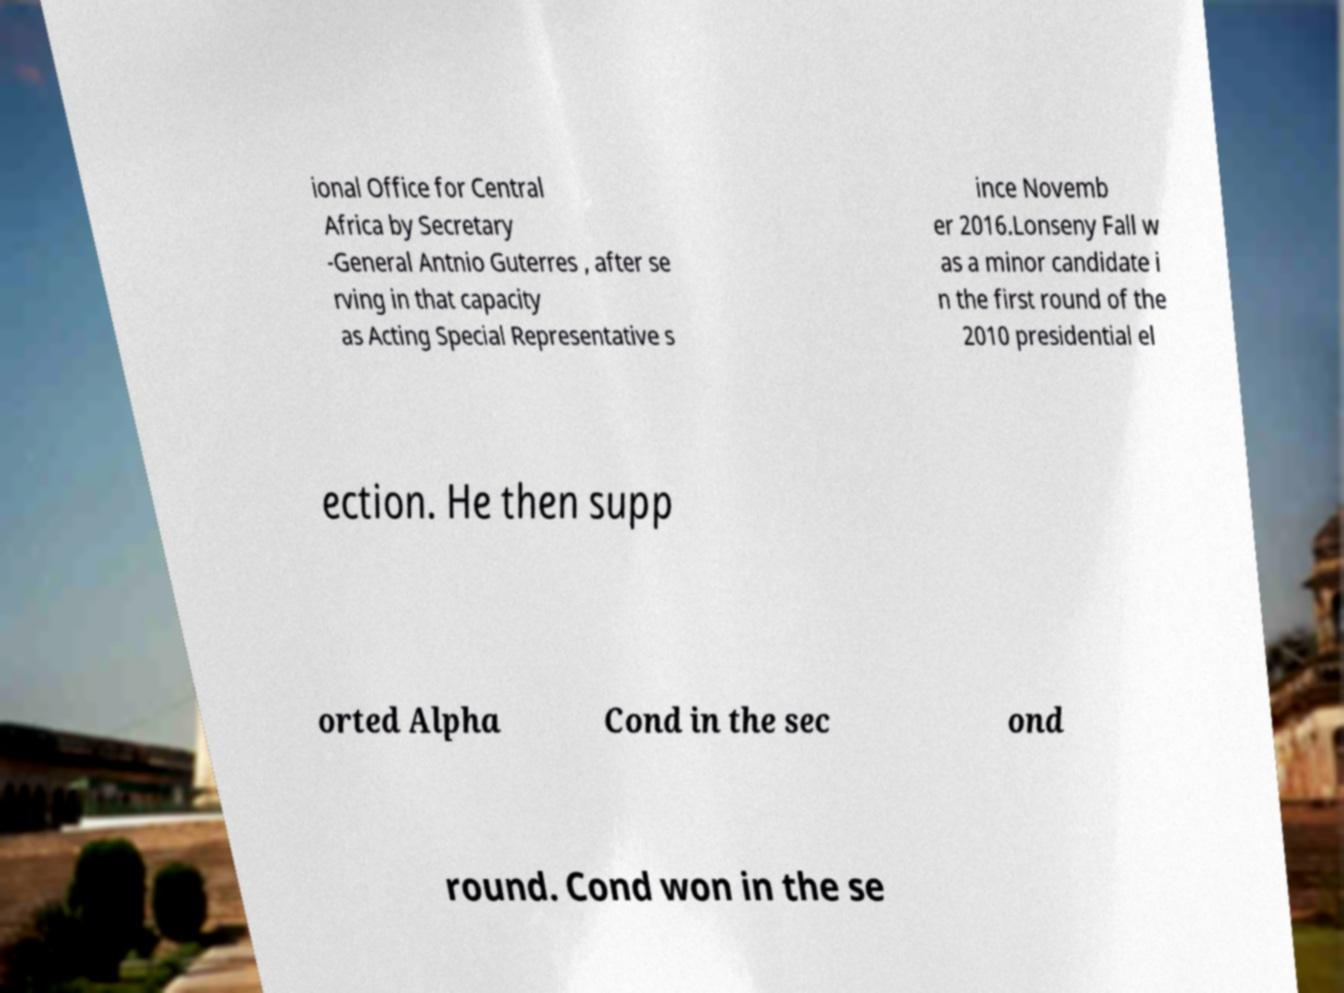What messages or text are displayed in this image? I need them in a readable, typed format. ional Office for Central Africa by Secretary -General Antnio Guterres , after se rving in that capacity as Acting Special Representative s ince Novemb er 2016.Lonseny Fall w as a minor candidate i n the first round of the 2010 presidential el ection. He then supp orted Alpha Cond in the sec ond round. Cond won in the se 